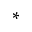<formula> <loc_0><loc_0><loc_500><loc_500>^ { * }</formula> 